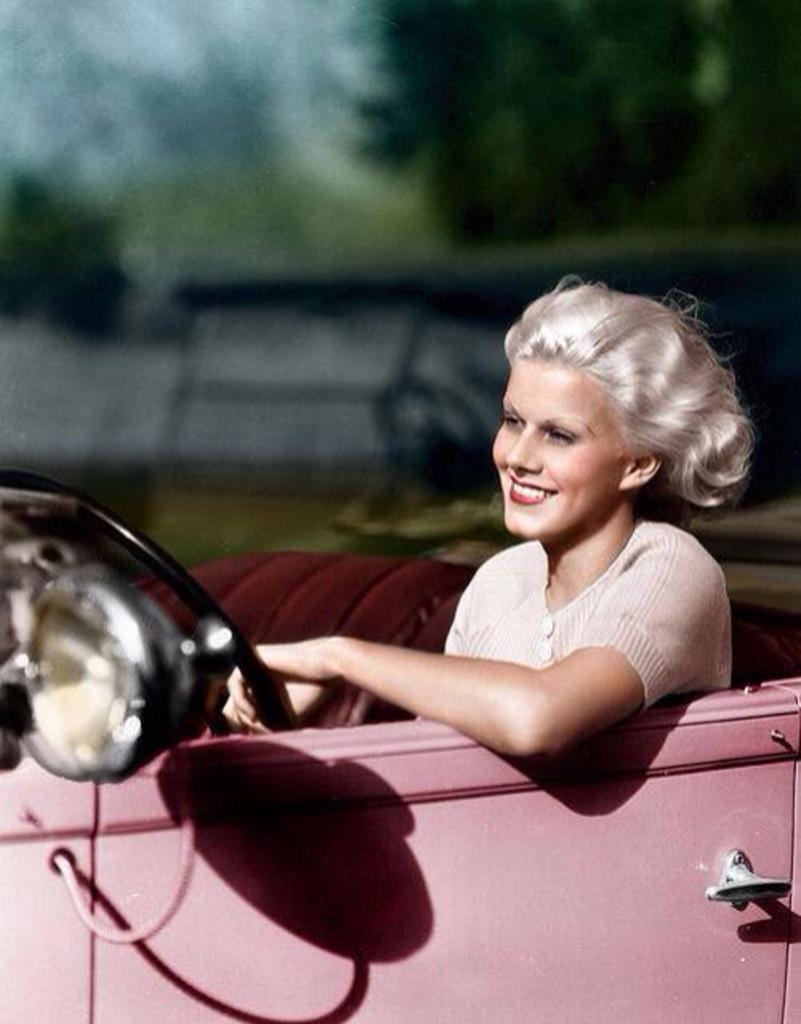Who is present in the image? There is a woman in the image. What is the woman doing in the image? The woman is seated in a car. What is the woman's facial expression in the image? The woman is smiling. What type of paper is burning in the image? There is no paper or flame present in the image; it features a woman seated in a car and smiling. 